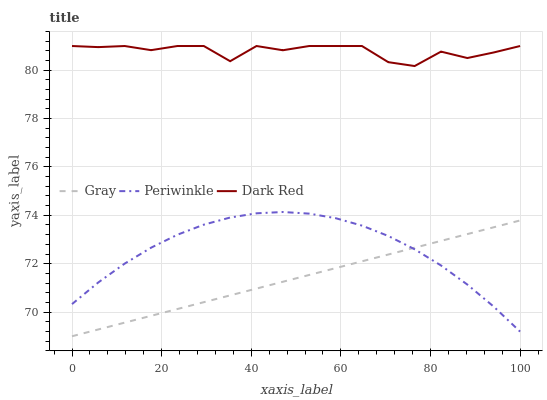Does Gray have the minimum area under the curve?
Answer yes or no. Yes. Does Dark Red have the maximum area under the curve?
Answer yes or no. Yes. Does Periwinkle have the minimum area under the curve?
Answer yes or no. No. Does Periwinkle have the maximum area under the curve?
Answer yes or no. No. Is Gray the smoothest?
Answer yes or no. Yes. Is Dark Red the roughest?
Answer yes or no. Yes. Is Periwinkle the smoothest?
Answer yes or no. No. Is Periwinkle the roughest?
Answer yes or no. No. Does Gray have the lowest value?
Answer yes or no. Yes. Does Periwinkle have the lowest value?
Answer yes or no. No. Does Dark Red have the highest value?
Answer yes or no. Yes. Does Periwinkle have the highest value?
Answer yes or no. No. Is Gray less than Dark Red?
Answer yes or no. Yes. Is Dark Red greater than Periwinkle?
Answer yes or no. Yes. Does Gray intersect Periwinkle?
Answer yes or no. Yes. Is Gray less than Periwinkle?
Answer yes or no. No. Is Gray greater than Periwinkle?
Answer yes or no. No. Does Gray intersect Dark Red?
Answer yes or no. No. 